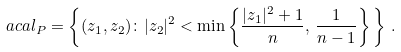Convert formula to latex. <formula><loc_0><loc_0><loc_500><loc_500>\ a c a l _ { P } = \left \{ ( z _ { 1 } , z _ { 2 } ) \colon | z _ { 2 } | ^ { 2 } < \min \left \{ \frac { | z _ { 1 } | ^ { 2 } + 1 } { n } , \, \frac { 1 } { n - 1 } \right \} \, \right \} \, .</formula> 